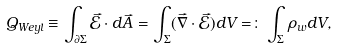Convert formula to latex. <formula><loc_0><loc_0><loc_500><loc_500>Q _ { W e y l } \equiv \int _ { \partial \Sigma } \vec { \mathcal { E } } \cdot d \vec { A } = \int _ { \Sigma } ( \vec { \nabla } \cdot \vec { \mathcal { E } } ) d V = \colon \int _ { \Sigma } \rho _ { w } d V ,</formula> 